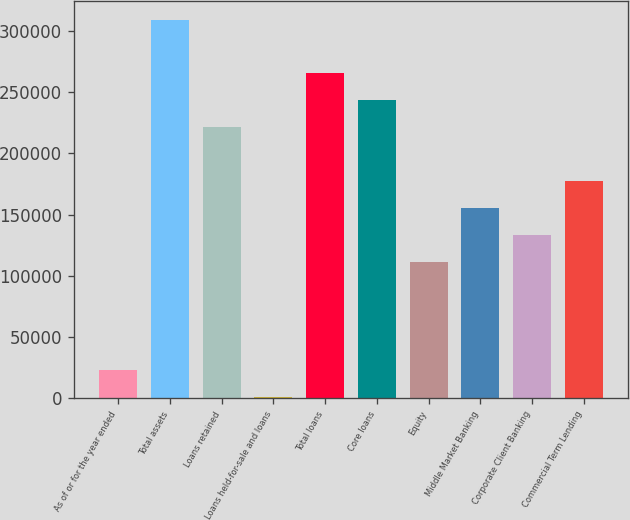Convert chart. <chart><loc_0><loc_0><loc_500><loc_500><bar_chart><fcel>As of or for the year ended<fcel>Total assets<fcel>Loans retained<fcel>Loans held-for-sale and loans<fcel>Total loans<fcel>Core loans<fcel>Equity<fcel>Middle Market Banking<fcel>Corporate Client Banking<fcel>Commercial Term Lending<nl><fcel>23280.2<fcel>309205<fcel>221228<fcel>1286<fcel>265216<fcel>243222<fcel>111257<fcel>155245<fcel>133251<fcel>177240<nl></chart> 